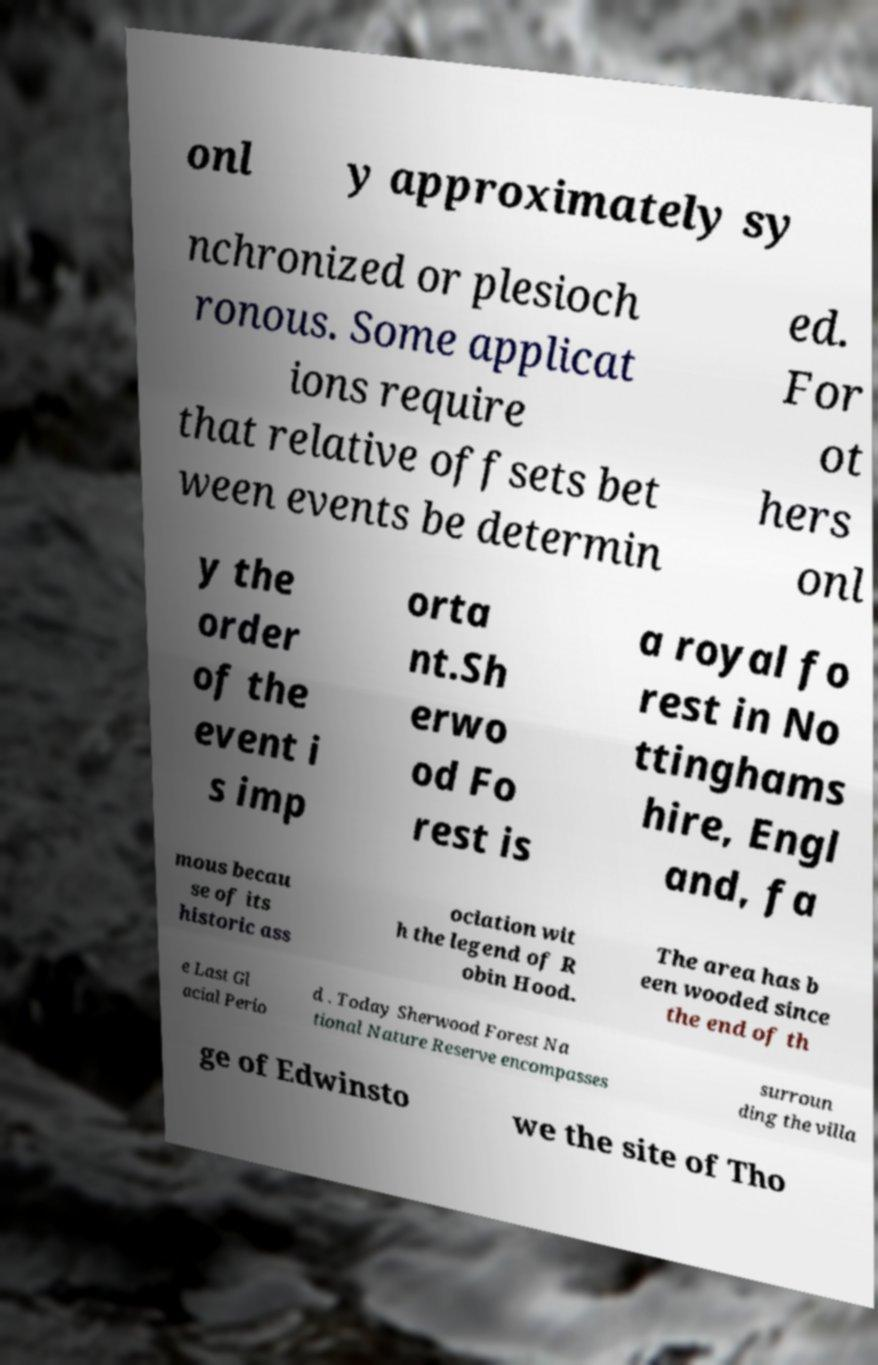Please read and relay the text visible in this image. What does it say? onl y approximately sy nchronized or plesioch ronous. Some applicat ions require that relative offsets bet ween events be determin ed. For ot hers onl y the order of the event i s imp orta nt.Sh erwo od Fo rest is a royal fo rest in No ttinghams hire, Engl and, fa mous becau se of its historic ass ociation wit h the legend of R obin Hood. The area has b een wooded since the end of th e Last Gl acial Perio d . Today Sherwood Forest Na tional Nature Reserve encompasses surroun ding the villa ge of Edwinsto we the site of Tho 